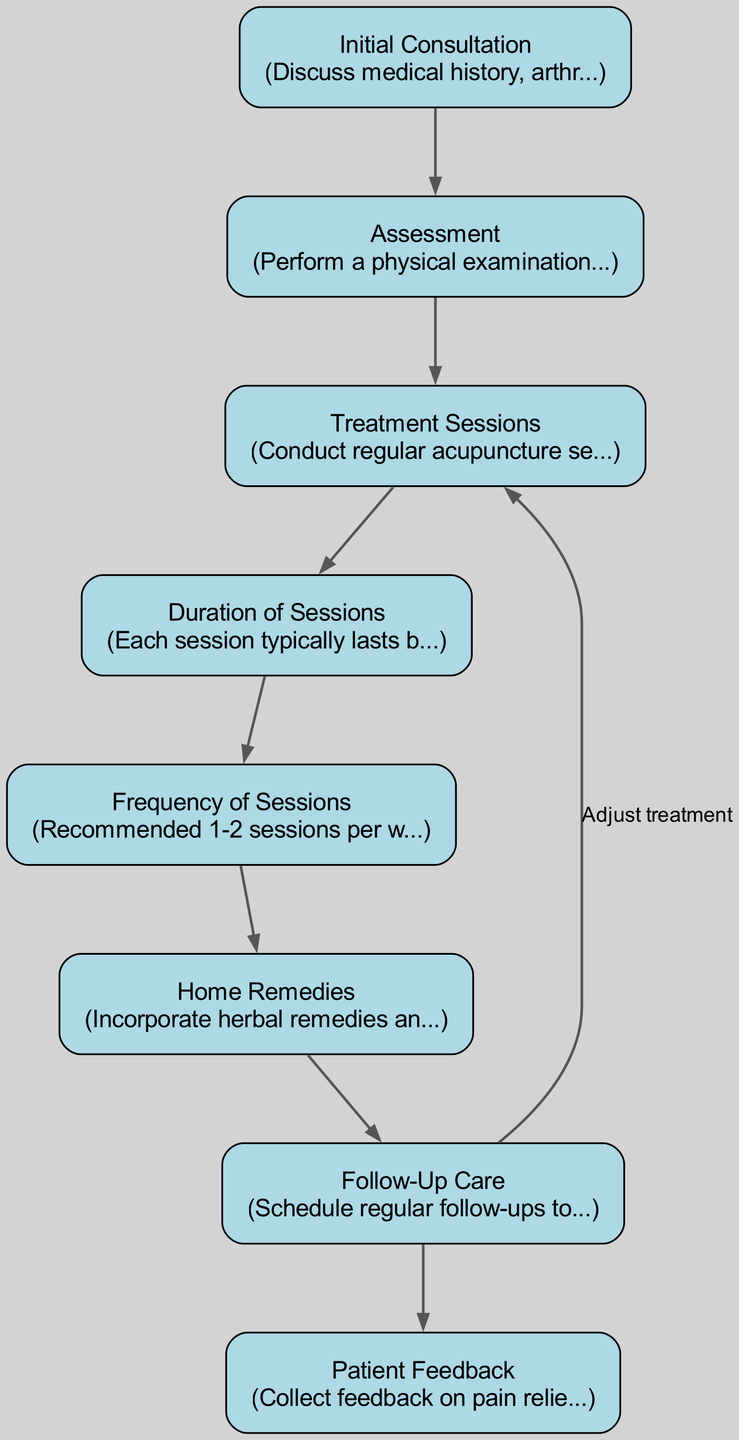What is the first step in the acupuncture treatment process? The diagram lists "Initial Consultation" as the first node where the process begins, indicating that this is the starting point.
Answer: Initial Consultation How many treatment sessions are typically recommended per week? The diagram states that "Frequency of Sessions" includes a recommendation of 1-2 sessions per week, combining information from the labeled node.
Answer: 1-2 What does the "Follow-Up Care" node guide the treatment towards? The diagram shows an arrow going from "Follow-Up Care" back to "Treatment Sessions" with the label "Adjust treatment," indicating that follow-up care is meant to guide adjustments in treatment.
Answer: Adjust treatment What is the duration range for each acupuncture session? The "Duration of Sessions" node explicitly states that each session typically lasts between 30 to 60 minutes, presenting this information directly.
Answer: 30 to 60 minutes Which part of the process involves assessing the patient's range of motion? The diagram indicates that "Assessment" involves performing a physical examination and assessment of the range of motion in affected joints, making it clear where this step occurs.
Answer: Assessment How many nodes are present in the acupuncture treatment process? By counting the individual labeled nodes provided in the diagram, there are eight unique nodes that describe different aspects of the treatment process.
Answer: 8 What complementary methods are suggested alongside treatment sessions? The "Home Remedies" node indicates the importance of incorporating herbal remedies and lifestyle changes to complement the acupuncture treatments, providing direct information from the diagram.
Answer: Herbal remedies and lifestyle changes What feedback is collected during the acupuncture treatment process? The "Patient Feedback" node indicates that feedback on pain relief and overall well-being is collected to inform ongoing treatment, detailing the purpose of this part of the process clearly.
Answer: Pain relief and overall well-being How does follow-up care check on treatment effectiveness? The diagram shows that "Patient Feedback" directly gathers input from the patient after "Follow-Up Care," indicating that feedback is essential for evaluating treatment effectiveness and guiding adjustments.
Answer: Feedback 